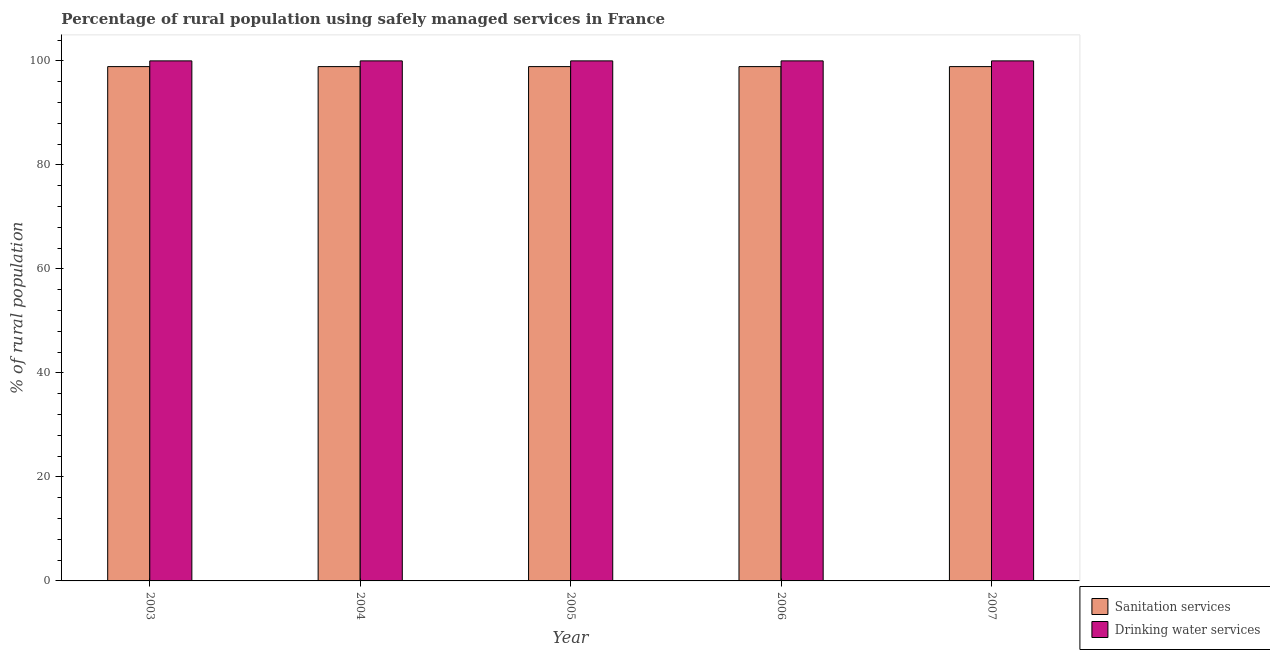Are the number of bars per tick equal to the number of legend labels?
Your answer should be very brief. Yes. How many bars are there on the 3rd tick from the left?
Your answer should be compact. 2. How many bars are there on the 2nd tick from the right?
Offer a very short reply. 2. In how many cases, is the number of bars for a given year not equal to the number of legend labels?
Your answer should be very brief. 0. What is the percentage of rural population who used sanitation services in 2006?
Offer a very short reply. 98.9. Across all years, what is the maximum percentage of rural population who used sanitation services?
Offer a very short reply. 98.9. Across all years, what is the minimum percentage of rural population who used sanitation services?
Offer a terse response. 98.9. In which year was the percentage of rural population who used drinking water services maximum?
Make the answer very short. 2003. In which year was the percentage of rural population who used drinking water services minimum?
Your response must be concise. 2003. What is the total percentage of rural population who used drinking water services in the graph?
Your answer should be very brief. 500. What is the average percentage of rural population who used sanitation services per year?
Offer a very short reply. 98.9. In the year 2006, what is the difference between the percentage of rural population who used sanitation services and percentage of rural population who used drinking water services?
Make the answer very short. 0. Is the percentage of rural population who used drinking water services in 2004 less than that in 2005?
Ensure brevity in your answer.  No. Is the difference between the percentage of rural population who used drinking water services in 2004 and 2005 greater than the difference between the percentage of rural population who used sanitation services in 2004 and 2005?
Your response must be concise. No. What is the difference between the highest and the second highest percentage of rural population who used drinking water services?
Provide a short and direct response. 0. What is the difference between the highest and the lowest percentage of rural population who used sanitation services?
Keep it short and to the point. 0. What does the 1st bar from the left in 2007 represents?
Offer a terse response. Sanitation services. What does the 2nd bar from the right in 2004 represents?
Keep it short and to the point. Sanitation services. Are all the bars in the graph horizontal?
Offer a very short reply. No. How many years are there in the graph?
Your answer should be compact. 5. Are the values on the major ticks of Y-axis written in scientific E-notation?
Your response must be concise. No. Does the graph contain grids?
Offer a terse response. No. How are the legend labels stacked?
Make the answer very short. Vertical. What is the title of the graph?
Your response must be concise. Percentage of rural population using safely managed services in France. What is the label or title of the Y-axis?
Ensure brevity in your answer.  % of rural population. What is the % of rural population in Sanitation services in 2003?
Provide a succinct answer. 98.9. What is the % of rural population in Drinking water services in 2003?
Offer a terse response. 100. What is the % of rural population of Sanitation services in 2004?
Your response must be concise. 98.9. What is the % of rural population of Drinking water services in 2004?
Your response must be concise. 100. What is the % of rural population of Sanitation services in 2005?
Offer a very short reply. 98.9. What is the % of rural population of Drinking water services in 2005?
Provide a succinct answer. 100. What is the % of rural population of Sanitation services in 2006?
Keep it short and to the point. 98.9. What is the % of rural population in Drinking water services in 2006?
Your response must be concise. 100. What is the % of rural population in Sanitation services in 2007?
Keep it short and to the point. 98.9. What is the % of rural population in Drinking water services in 2007?
Keep it short and to the point. 100. Across all years, what is the maximum % of rural population in Sanitation services?
Give a very brief answer. 98.9. Across all years, what is the maximum % of rural population of Drinking water services?
Your answer should be compact. 100. Across all years, what is the minimum % of rural population in Sanitation services?
Offer a terse response. 98.9. Across all years, what is the minimum % of rural population of Drinking water services?
Make the answer very short. 100. What is the total % of rural population in Sanitation services in the graph?
Make the answer very short. 494.5. What is the difference between the % of rural population in Sanitation services in 2003 and that in 2005?
Give a very brief answer. 0. What is the difference between the % of rural population of Drinking water services in 2003 and that in 2006?
Your answer should be compact. 0. What is the difference between the % of rural population in Sanitation services in 2004 and that in 2005?
Make the answer very short. 0. What is the difference between the % of rural population of Sanitation services in 2004 and that in 2006?
Your answer should be very brief. 0. What is the difference between the % of rural population of Drinking water services in 2004 and that in 2006?
Ensure brevity in your answer.  0. What is the difference between the % of rural population of Sanitation services in 2004 and that in 2007?
Provide a succinct answer. 0. What is the difference between the % of rural population in Sanitation services in 2005 and that in 2006?
Make the answer very short. 0. What is the difference between the % of rural population in Sanitation services in 2006 and that in 2007?
Provide a succinct answer. 0. What is the difference between the % of rural population of Sanitation services in 2003 and the % of rural population of Drinking water services in 2004?
Ensure brevity in your answer.  -1.1. What is the difference between the % of rural population of Sanitation services in 2003 and the % of rural population of Drinking water services in 2007?
Your answer should be very brief. -1.1. What is the difference between the % of rural population of Sanitation services in 2004 and the % of rural population of Drinking water services in 2007?
Give a very brief answer. -1.1. What is the difference between the % of rural population in Sanitation services in 2005 and the % of rural population in Drinking water services in 2007?
Keep it short and to the point. -1.1. What is the difference between the % of rural population in Sanitation services in 2006 and the % of rural population in Drinking water services in 2007?
Your answer should be compact. -1.1. What is the average % of rural population of Sanitation services per year?
Your response must be concise. 98.9. In the year 2003, what is the difference between the % of rural population in Sanitation services and % of rural population in Drinking water services?
Ensure brevity in your answer.  -1.1. In the year 2004, what is the difference between the % of rural population of Sanitation services and % of rural population of Drinking water services?
Give a very brief answer. -1.1. What is the ratio of the % of rural population in Sanitation services in 2003 to that in 2004?
Offer a terse response. 1. What is the ratio of the % of rural population in Drinking water services in 2003 to that in 2005?
Offer a terse response. 1. What is the ratio of the % of rural population in Sanitation services in 2003 to that in 2007?
Your answer should be very brief. 1. What is the ratio of the % of rural population of Sanitation services in 2004 to that in 2005?
Your response must be concise. 1. What is the ratio of the % of rural population of Sanitation services in 2004 to that in 2006?
Ensure brevity in your answer.  1. What is the ratio of the % of rural population in Drinking water services in 2004 to that in 2006?
Offer a very short reply. 1. What is the ratio of the % of rural population of Sanitation services in 2005 to that in 2006?
Keep it short and to the point. 1. What is the ratio of the % of rural population of Drinking water services in 2005 to that in 2006?
Provide a succinct answer. 1. What is the ratio of the % of rural population in Sanitation services in 2006 to that in 2007?
Your response must be concise. 1. What is the difference between the highest and the second highest % of rural population in Sanitation services?
Offer a terse response. 0. What is the difference between the highest and the second highest % of rural population of Drinking water services?
Make the answer very short. 0. What is the difference between the highest and the lowest % of rural population of Sanitation services?
Offer a very short reply. 0. What is the difference between the highest and the lowest % of rural population in Drinking water services?
Provide a short and direct response. 0. 